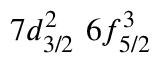Convert formula to latex. <formula><loc_0><loc_0><loc_500><loc_500>7 d _ { 3 / 2 } ^ { 2 } \, 6 f _ { 5 / 2 } ^ { 3 }</formula> 